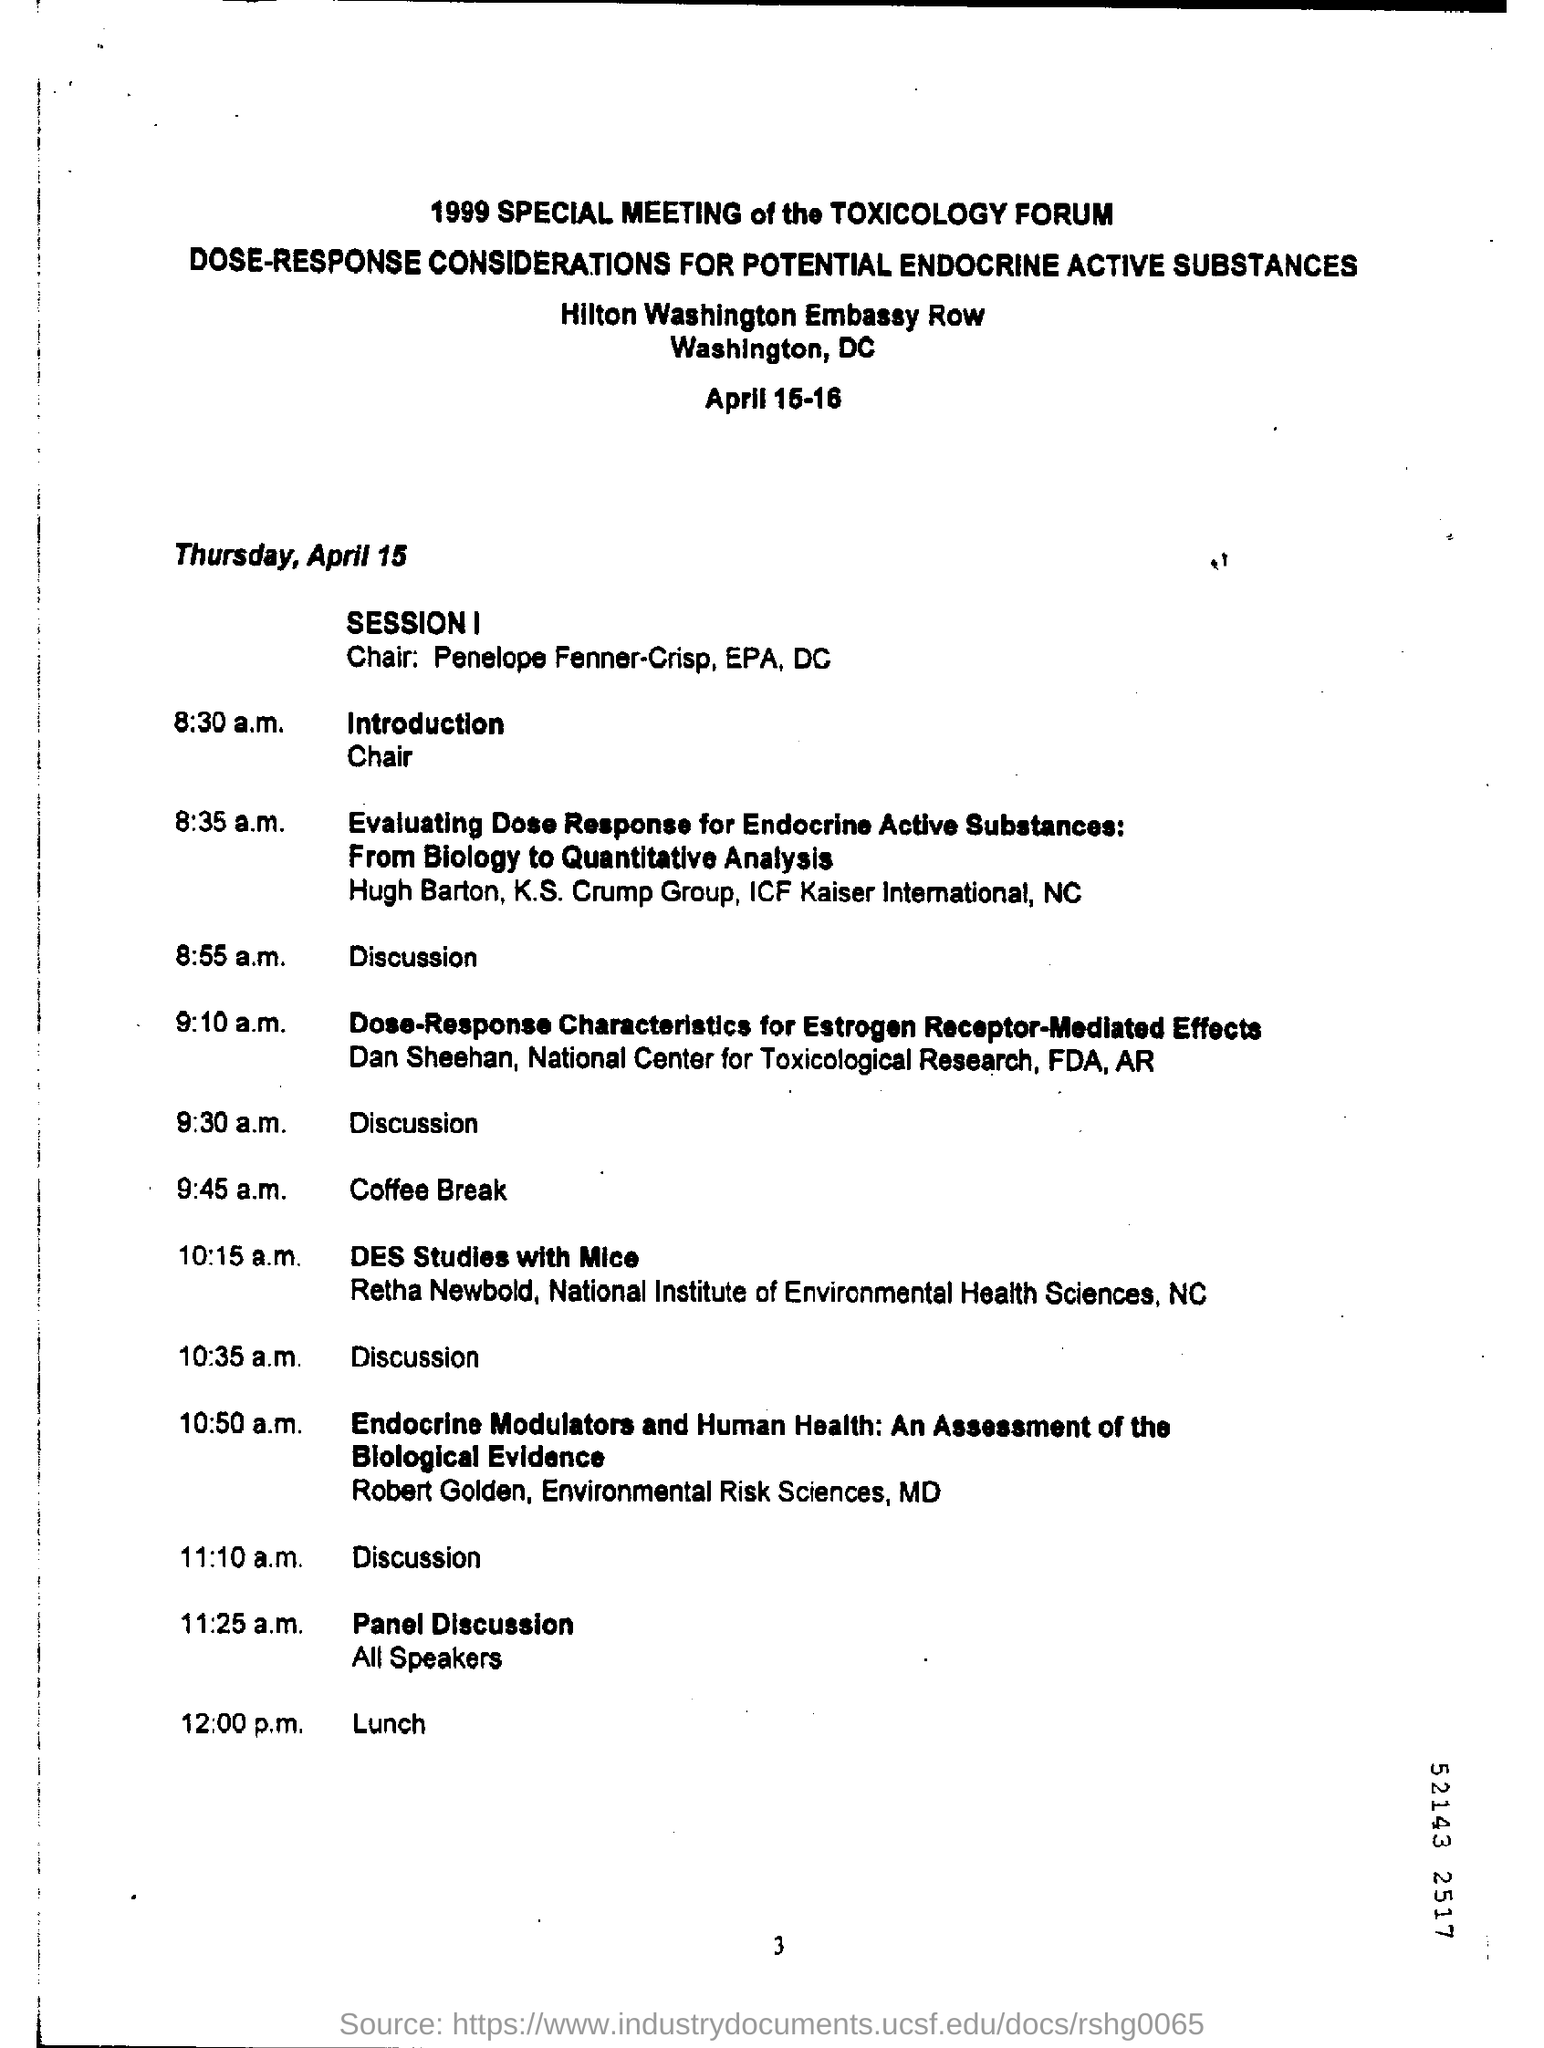When is the Introduction?
Offer a very short reply. 8:30 a.m. When is the panel Discussion?
Provide a short and direct response. 11:25 a.m. 